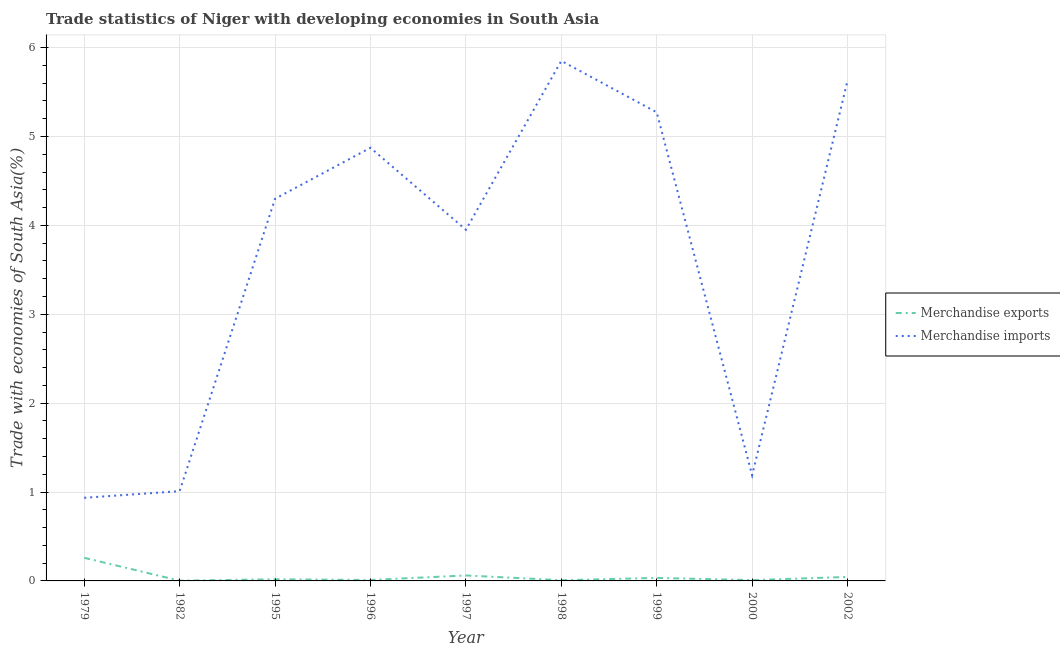What is the merchandise imports in 1982?
Your answer should be very brief. 1.01. Across all years, what is the maximum merchandise imports?
Give a very brief answer. 5.85. Across all years, what is the minimum merchandise imports?
Offer a terse response. 0.94. In which year was the merchandise exports maximum?
Offer a very short reply. 1979. In which year was the merchandise imports minimum?
Keep it short and to the point. 1979. What is the total merchandise imports in the graph?
Your answer should be very brief. 33.01. What is the difference between the merchandise imports in 1979 and that in 1999?
Keep it short and to the point. -4.34. What is the difference between the merchandise exports in 1997 and the merchandise imports in 2002?
Your answer should be very brief. -5.57. What is the average merchandise imports per year?
Provide a succinct answer. 3.67. In the year 2000, what is the difference between the merchandise imports and merchandise exports?
Your answer should be very brief. 1.18. In how many years, is the merchandise imports greater than 1.6 %?
Give a very brief answer. 6. What is the ratio of the merchandise imports in 1998 to that in 1999?
Provide a short and direct response. 1.11. What is the difference between the highest and the second highest merchandise imports?
Provide a short and direct response. 0.22. What is the difference between the highest and the lowest merchandise imports?
Keep it short and to the point. 4.92. Is the sum of the merchandise imports in 1995 and 2000 greater than the maximum merchandise exports across all years?
Keep it short and to the point. Yes. Is the merchandise imports strictly less than the merchandise exports over the years?
Keep it short and to the point. No. How many lines are there?
Your response must be concise. 2. What is the difference between two consecutive major ticks on the Y-axis?
Keep it short and to the point. 1. Are the values on the major ticks of Y-axis written in scientific E-notation?
Give a very brief answer. No. Does the graph contain grids?
Ensure brevity in your answer.  Yes. How many legend labels are there?
Offer a terse response. 2. What is the title of the graph?
Your answer should be compact. Trade statistics of Niger with developing economies in South Asia. What is the label or title of the Y-axis?
Give a very brief answer. Trade with economies of South Asia(%). What is the Trade with economies of South Asia(%) in Merchandise exports in 1979?
Offer a very short reply. 0.26. What is the Trade with economies of South Asia(%) of Merchandise imports in 1979?
Offer a very short reply. 0.94. What is the Trade with economies of South Asia(%) in Merchandise exports in 1982?
Give a very brief answer. 0. What is the Trade with economies of South Asia(%) in Merchandise imports in 1982?
Provide a short and direct response. 1.01. What is the Trade with economies of South Asia(%) of Merchandise exports in 1995?
Provide a short and direct response. 0.02. What is the Trade with economies of South Asia(%) in Merchandise imports in 1995?
Your response must be concise. 4.3. What is the Trade with economies of South Asia(%) in Merchandise exports in 1996?
Provide a short and direct response. 0.01. What is the Trade with economies of South Asia(%) of Merchandise imports in 1996?
Your answer should be very brief. 4.87. What is the Trade with economies of South Asia(%) in Merchandise exports in 1997?
Give a very brief answer. 0.06. What is the Trade with economies of South Asia(%) of Merchandise imports in 1997?
Ensure brevity in your answer.  3.95. What is the Trade with economies of South Asia(%) of Merchandise exports in 1998?
Offer a terse response. 0.01. What is the Trade with economies of South Asia(%) in Merchandise imports in 1998?
Offer a very short reply. 5.85. What is the Trade with economies of South Asia(%) in Merchandise exports in 1999?
Your response must be concise. 0.03. What is the Trade with economies of South Asia(%) in Merchandise imports in 1999?
Offer a very short reply. 5.27. What is the Trade with economies of South Asia(%) of Merchandise exports in 2000?
Your response must be concise. 0.01. What is the Trade with economies of South Asia(%) in Merchandise imports in 2000?
Make the answer very short. 1.19. What is the Trade with economies of South Asia(%) in Merchandise exports in 2002?
Make the answer very short. 0.04. What is the Trade with economies of South Asia(%) of Merchandise imports in 2002?
Provide a short and direct response. 5.63. Across all years, what is the maximum Trade with economies of South Asia(%) of Merchandise exports?
Your answer should be very brief. 0.26. Across all years, what is the maximum Trade with economies of South Asia(%) in Merchandise imports?
Provide a succinct answer. 5.85. Across all years, what is the minimum Trade with economies of South Asia(%) of Merchandise exports?
Your answer should be compact. 0. Across all years, what is the minimum Trade with economies of South Asia(%) in Merchandise imports?
Your answer should be compact. 0.94. What is the total Trade with economies of South Asia(%) in Merchandise exports in the graph?
Your answer should be very brief. 0.45. What is the total Trade with economies of South Asia(%) in Merchandise imports in the graph?
Your answer should be very brief. 33.01. What is the difference between the Trade with economies of South Asia(%) in Merchandise exports in 1979 and that in 1982?
Offer a terse response. 0.26. What is the difference between the Trade with economies of South Asia(%) of Merchandise imports in 1979 and that in 1982?
Your response must be concise. -0.07. What is the difference between the Trade with economies of South Asia(%) of Merchandise exports in 1979 and that in 1995?
Your answer should be very brief. 0.24. What is the difference between the Trade with economies of South Asia(%) in Merchandise imports in 1979 and that in 1995?
Provide a short and direct response. -3.36. What is the difference between the Trade with economies of South Asia(%) in Merchandise exports in 1979 and that in 1996?
Ensure brevity in your answer.  0.25. What is the difference between the Trade with economies of South Asia(%) in Merchandise imports in 1979 and that in 1996?
Offer a terse response. -3.94. What is the difference between the Trade with economies of South Asia(%) of Merchandise exports in 1979 and that in 1997?
Keep it short and to the point. 0.2. What is the difference between the Trade with economies of South Asia(%) in Merchandise imports in 1979 and that in 1997?
Offer a terse response. -3.02. What is the difference between the Trade with economies of South Asia(%) of Merchandise exports in 1979 and that in 1998?
Make the answer very short. 0.25. What is the difference between the Trade with economies of South Asia(%) of Merchandise imports in 1979 and that in 1998?
Offer a very short reply. -4.92. What is the difference between the Trade with economies of South Asia(%) of Merchandise exports in 1979 and that in 1999?
Keep it short and to the point. 0.23. What is the difference between the Trade with economies of South Asia(%) of Merchandise imports in 1979 and that in 1999?
Keep it short and to the point. -4.34. What is the difference between the Trade with economies of South Asia(%) of Merchandise exports in 1979 and that in 2000?
Provide a short and direct response. 0.25. What is the difference between the Trade with economies of South Asia(%) of Merchandise imports in 1979 and that in 2000?
Provide a short and direct response. -0.25. What is the difference between the Trade with economies of South Asia(%) in Merchandise exports in 1979 and that in 2002?
Your response must be concise. 0.22. What is the difference between the Trade with economies of South Asia(%) in Merchandise imports in 1979 and that in 2002?
Provide a short and direct response. -4.69. What is the difference between the Trade with economies of South Asia(%) of Merchandise exports in 1982 and that in 1995?
Give a very brief answer. -0.02. What is the difference between the Trade with economies of South Asia(%) of Merchandise imports in 1982 and that in 1995?
Provide a succinct answer. -3.29. What is the difference between the Trade with economies of South Asia(%) in Merchandise exports in 1982 and that in 1996?
Offer a terse response. -0.01. What is the difference between the Trade with economies of South Asia(%) of Merchandise imports in 1982 and that in 1996?
Provide a short and direct response. -3.86. What is the difference between the Trade with economies of South Asia(%) in Merchandise exports in 1982 and that in 1997?
Your answer should be compact. -0.06. What is the difference between the Trade with economies of South Asia(%) in Merchandise imports in 1982 and that in 1997?
Provide a short and direct response. -2.94. What is the difference between the Trade with economies of South Asia(%) in Merchandise exports in 1982 and that in 1998?
Your answer should be very brief. -0.01. What is the difference between the Trade with economies of South Asia(%) of Merchandise imports in 1982 and that in 1998?
Provide a short and direct response. -4.84. What is the difference between the Trade with economies of South Asia(%) in Merchandise exports in 1982 and that in 1999?
Your answer should be very brief. -0.03. What is the difference between the Trade with economies of South Asia(%) in Merchandise imports in 1982 and that in 1999?
Keep it short and to the point. -4.26. What is the difference between the Trade with economies of South Asia(%) of Merchandise exports in 1982 and that in 2000?
Offer a very short reply. -0.01. What is the difference between the Trade with economies of South Asia(%) in Merchandise imports in 1982 and that in 2000?
Make the answer very short. -0.18. What is the difference between the Trade with economies of South Asia(%) of Merchandise exports in 1982 and that in 2002?
Make the answer very short. -0.04. What is the difference between the Trade with economies of South Asia(%) of Merchandise imports in 1982 and that in 2002?
Keep it short and to the point. -4.62. What is the difference between the Trade with economies of South Asia(%) in Merchandise exports in 1995 and that in 1996?
Provide a succinct answer. 0.01. What is the difference between the Trade with economies of South Asia(%) in Merchandise imports in 1995 and that in 1996?
Make the answer very short. -0.57. What is the difference between the Trade with economies of South Asia(%) in Merchandise exports in 1995 and that in 1997?
Offer a very short reply. -0.04. What is the difference between the Trade with economies of South Asia(%) in Merchandise imports in 1995 and that in 1997?
Your answer should be very brief. 0.35. What is the difference between the Trade with economies of South Asia(%) in Merchandise exports in 1995 and that in 1998?
Offer a very short reply. 0.01. What is the difference between the Trade with economies of South Asia(%) of Merchandise imports in 1995 and that in 1998?
Keep it short and to the point. -1.55. What is the difference between the Trade with economies of South Asia(%) in Merchandise exports in 1995 and that in 1999?
Keep it short and to the point. -0.01. What is the difference between the Trade with economies of South Asia(%) in Merchandise imports in 1995 and that in 1999?
Your response must be concise. -0.97. What is the difference between the Trade with economies of South Asia(%) of Merchandise exports in 1995 and that in 2000?
Your answer should be very brief. 0.01. What is the difference between the Trade with economies of South Asia(%) in Merchandise imports in 1995 and that in 2000?
Provide a short and direct response. 3.11. What is the difference between the Trade with economies of South Asia(%) in Merchandise exports in 1995 and that in 2002?
Provide a short and direct response. -0.03. What is the difference between the Trade with economies of South Asia(%) of Merchandise imports in 1995 and that in 2002?
Make the answer very short. -1.33. What is the difference between the Trade with economies of South Asia(%) in Merchandise exports in 1996 and that in 1997?
Provide a succinct answer. -0.05. What is the difference between the Trade with economies of South Asia(%) in Merchandise imports in 1996 and that in 1997?
Provide a short and direct response. 0.92. What is the difference between the Trade with economies of South Asia(%) of Merchandise exports in 1996 and that in 1998?
Provide a succinct answer. 0. What is the difference between the Trade with economies of South Asia(%) in Merchandise imports in 1996 and that in 1998?
Ensure brevity in your answer.  -0.98. What is the difference between the Trade with economies of South Asia(%) of Merchandise exports in 1996 and that in 1999?
Keep it short and to the point. -0.02. What is the difference between the Trade with economies of South Asia(%) in Merchandise imports in 1996 and that in 1999?
Offer a terse response. -0.4. What is the difference between the Trade with economies of South Asia(%) of Merchandise exports in 1996 and that in 2000?
Offer a very short reply. 0. What is the difference between the Trade with economies of South Asia(%) in Merchandise imports in 1996 and that in 2000?
Make the answer very short. 3.68. What is the difference between the Trade with economies of South Asia(%) of Merchandise exports in 1996 and that in 2002?
Provide a short and direct response. -0.03. What is the difference between the Trade with economies of South Asia(%) in Merchandise imports in 1996 and that in 2002?
Keep it short and to the point. -0.76. What is the difference between the Trade with economies of South Asia(%) of Merchandise exports in 1997 and that in 1998?
Keep it short and to the point. 0.05. What is the difference between the Trade with economies of South Asia(%) in Merchandise imports in 1997 and that in 1998?
Your response must be concise. -1.9. What is the difference between the Trade with economies of South Asia(%) of Merchandise exports in 1997 and that in 1999?
Your answer should be compact. 0.03. What is the difference between the Trade with economies of South Asia(%) of Merchandise imports in 1997 and that in 1999?
Your answer should be very brief. -1.32. What is the difference between the Trade with economies of South Asia(%) in Merchandise exports in 1997 and that in 2000?
Make the answer very short. 0.05. What is the difference between the Trade with economies of South Asia(%) in Merchandise imports in 1997 and that in 2000?
Offer a very short reply. 2.76. What is the difference between the Trade with economies of South Asia(%) in Merchandise exports in 1997 and that in 2002?
Offer a very short reply. 0.02. What is the difference between the Trade with economies of South Asia(%) of Merchandise imports in 1997 and that in 2002?
Keep it short and to the point. -1.68. What is the difference between the Trade with economies of South Asia(%) of Merchandise exports in 1998 and that in 1999?
Make the answer very short. -0.03. What is the difference between the Trade with economies of South Asia(%) of Merchandise imports in 1998 and that in 1999?
Your answer should be compact. 0.58. What is the difference between the Trade with economies of South Asia(%) of Merchandise exports in 1998 and that in 2000?
Ensure brevity in your answer.  -0. What is the difference between the Trade with economies of South Asia(%) in Merchandise imports in 1998 and that in 2000?
Your response must be concise. 4.66. What is the difference between the Trade with economies of South Asia(%) of Merchandise exports in 1998 and that in 2002?
Ensure brevity in your answer.  -0.04. What is the difference between the Trade with economies of South Asia(%) of Merchandise imports in 1998 and that in 2002?
Offer a very short reply. 0.22. What is the difference between the Trade with economies of South Asia(%) of Merchandise exports in 1999 and that in 2000?
Your response must be concise. 0.02. What is the difference between the Trade with economies of South Asia(%) in Merchandise imports in 1999 and that in 2000?
Your answer should be compact. 4.08. What is the difference between the Trade with economies of South Asia(%) of Merchandise exports in 1999 and that in 2002?
Keep it short and to the point. -0.01. What is the difference between the Trade with economies of South Asia(%) in Merchandise imports in 1999 and that in 2002?
Offer a very short reply. -0.36. What is the difference between the Trade with economies of South Asia(%) of Merchandise exports in 2000 and that in 2002?
Your answer should be very brief. -0.04. What is the difference between the Trade with economies of South Asia(%) of Merchandise imports in 2000 and that in 2002?
Give a very brief answer. -4.44. What is the difference between the Trade with economies of South Asia(%) of Merchandise exports in 1979 and the Trade with economies of South Asia(%) of Merchandise imports in 1982?
Ensure brevity in your answer.  -0.75. What is the difference between the Trade with economies of South Asia(%) of Merchandise exports in 1979 and the Trade with economies of South Asia(%) of Merchandise imports in 1995?
Provide a short and direct response. -4.04. What is the difference between the Trade with economies of South Asia(%) in Merchandise exports in 1979 and the Trade with economies of South Asia(%) in Merchandise imports in 1996?
Keep it short and to the point. -4.61. What is the difference between the Trade with economies of South Asia(%) in Merchandise exports in 1979 and the Trade with economies of South Asia(%) in Merchandise imports in 1997?
Your answer should be compact. -3.69. What is the difference between the Trade with economies of South Asia(%) in Merchandise exports in 1979 and the Trade with economies of South Asia(%) in Merchandise imports in 1998?
Provide a short and direct response. -5.59. What is the difference between the Trade with economies of South Asia(%) in Merchandise exports in 1979 and the Trade with economies of South Asia(%) in Merchandise imports in 1999?
Your answer should be very brief. -5.01. What is the difference between the Trade with economies of South Asia(%) in Merchandise exports in 1979 and the Trade with economies of South Asia(%) in Merchandise imports in 2000?
Your answer should be compact. -0.93. What is the difference between the Trade with economies of South Asia(%) of Merchandise exports in 1979 and the Trade with economies of South Asia(%) of Merchandise imports in 2002?
Give a very brief answer. -5.37. What is the difference between the Trade with economies of South Asia(%) in Merchandise exports in 1982 and the Trade with economies of South Asia(%) in Merchandise imports in 1995?
Provide a succinct answer. -4.3. What is the difference between the Trade with economies of South Asia(%) in Merchandise exports in 1982 and the Trade with economies of South Asia(%) in Merchandise imports in 1996?
Make the answer very short. -4.87. What is the difference between the Trade with economies of South Asia(%) in Merchandise exports in 1982 and the Trade with economies of South Asia(%) in Merchandise imports in 1997?
Your answer should be compact. -3.95. What is the difference between the Trade with economies of South Asia(%) of Merchandise exports in 1982 and the Trade with economies of South Asia(%) of Merchandise imports in 1998?
Provide a short and direct response. -5.85. What is the difference between the Trade with economies of South Asia(%) of Merchandise exports in 1982 and the Trade with economies of South Asia(%) of Merchandise imports in 1999?
Provide a succinct answer. -5.27. What is the difference between the Trade with economies of South Asia(%) in Merchandise exports in 1982 and the Trade with economies of South Asia(%) in Merchandise imports in 2000?
Your answer should be compact. -1.19. What is the difference between the Trade with economies of South Asia(%) of Merchandise exports in 1982 and the Trade with economies of South Asia(%) of Merchandise imports in 2002?
Keep it short and to the point. -5.63. What is the difference between the Trade with economies of South Asia(%) of Merchandise exports in 1995 and the Trade with economies of South Asia(%) of Merchandise imports in 1996?
Offer a terse response. -4.85. What is the difference between the Trade with economies of South Asia(%) of Merchandise exports in 1995 and the Trade with economies of South Asia(%) of Merchandise imports in 1997?
Give a very brief answer. -3.93. What is the difference between the Trade with economies of South Asia(%) in Merchandise exports in 1995 and the Trade with economies of South Asia(%) in Merchandise imports in 1998?
Give a very brief answer. -5.83. What is the difference between the Trade with economies of South Asia(%) in Merchandise exports in 1995 and the Trade with economies of South Asia(%) in Merchandise imports in 1999?
Your answer should be very brief. -5.25. What is the difference between the Trade with economies of South Asia(%) of Merchandise exports in 1995 and the Trade with economies of South Asia(%) of Merchandise imports in 2000?
Offer a terse response. -1.17. What is the difference between the Trade with economies of South Asia(%) of Merchandise exports in 1995 and the Trade with economies of South Asia(%) of Merchandise imports in 2002?
Your answer should be very brief. -5.61. What is the difference between the Trade with economies of South Asia(%) in Merchandise exports in 1996 and the Trade with economies of South Asia(%) in Merchandise imports in 1997?
Make the answer very short. -3.94. What is the difference between the Trade with economies of South Asia(%) of Merchandise exports in 1996 and the Trade with economies of South Asia(%) of Merchandise imports in 1998?
Keep it short and to the point. -5.84. What is the difference between the Trade with economies of South Asia(%) in Merchandise exports in 1996 and the Trade with economies of South Asia(%) in Merchandise imports in 1999?
Your response must be concise. -5.26. What is the difference between the Trade with economies of South Asia(%) in Merchandise exports in 1996 and the Trade with economies of South Asia(%) in Merchandise imports in 2000?
Your answer should be very brief. -1.18. What is the difference between the Trade with economies of South Asia(%) of Merchandise exports in 1996 and the Trade with economies of South Asia(%) of Merchandise imports in 2002?
Your answer should be compact. -5.62. What is the difference between the Trade with economies of South Asia(%) in Merchandise exports in 1997 and the Trade with economies of South Asia(%) in Merchandise imports in 1998?
Give a very brief answer. -5.79. What is the difference between the Trade with economies of South Asia(%) of Merchandise exports in 1997 and the Trade with economies of South Asia(%) of Merchandise imports in 1999?
Provide a short and direct response. -5.21. What is the difference between the Trade with economies of South Asia(%) in Merchandise exports in 1997 and the Trade with economies of South Asia(%) in Merchandise imports in 2000?
Offer a terse response. -1.13. What is the difference between the Trade with economies of South Asia(%) of Merchandise exports in 1997 and the Trade with economies of South Asia(%) of Merchandise imports in 2002?
Make the answer very short. -5.57. What is the difference between the Trade with economies of South Asia(%) of Merchandise exports in 1998 and the Trade with economies of South Asia(%) of Merchandise imports in 1999?
Make the answer very short. -5.26. What is the difference between the Trade with economies of South Asia(%) in Merchandise exports in 1998 and the Trade with economies of South Asia(%) in Merchandise imports in 2000?
Offer a very short reply. -1.18. What is the difference between the Trade with economies of South Asia(%) of Merchandise exports in 1998 and the Trade with economies of South Asia(%) of Merchandise imports in 2002?
Give a very brief answer. -5.62. What is the difference between the Trade with economies of South Asia(%) of Merchandise exports in 1999 and the Trade with economies of South Asia(%) of Merchandise imports in 2000?
Give a very brief answer. -1.16. What is the difference between the Trade with economies of South Asia(%) of Merchandise exports in 1999 and the Trade with economies of South Asia(%) of Merchandise imports in 2002?
Keep it short and to the point. -5.6. What is the difference between the Trade with economies of South Asia(%) of Merchandise exports in 2000 and the Trade with economies of South Asia(%) of Merchandise imports in 2002?
Keep it short and to the point. -5.62. What is the average Trade with economies of South Asia(%) in Merchandise imports per year?
Your answer should be compact. 3.67. In the year 1979, what is the difference between the Trade with economies of South Asia(%) of Merchandise exports and Trade with economies of South Asia(%) of Merchandise imports?
Provide a short and direct response. -0.67. In the year 1982, what is the difference between the Trade with economies of South Asia(%) in Merchandise exports and Trade with economies of South Asia(%) in Merchandise imports?
Your response must be concise. -1.01. In the year 1995, what is the difference between the Trade with economies of South Asia(%) in Merchandise exports and Trade with economies of South Asia(%) in Merchandise imports?
Your answer should be compact. -4.28. In the year 1996, what is the difference between the Trade with economies of South Asia(%) in Merchandise exports and Trade with economies of South Asia(%) in Merchandise imports?
Provide a succinct answer. -4.86. In the year 1997, what is the difference between the Trade with economies of South Asia(%) in Merchandise exports and Trade with economies of South Asia(%) in Merchandise imports?
Your answer should be compact. -3.89. In the year 1998, what is the difference between the Trade with economies of South Asia(%) in Merchandise exports and Trade with economies of South Asia(%) in Merchandise imports?
Make the answer very short. -5.84. In the year 1999, what is the difference between the Trade with economies of South Asia(%) in Merchandise exports and Trade with economies of South Asia(%) in Merchandise imports?
Keep it short and to the point. -5.24. In the year 2000, what is the difference between the Trade with economies of South Asia(%) of Merchandise exports and Trade with economies of South Asia(%) of Merchandise imports?
Provide a short and direct response. -1.18. In the year 2002, what is the difference between the Trade with economies of South Asia(%) of Merchandise exports and Trade with economies of South Asia(%) of Merchandise imports?
Your answer should be compact. -5.58. What is the ratio of the Trade with economies of South Asia(%) in Merchandise exports in 1979 to that in 1982?
Ensure brevity in your answer.  95.98. What is the ratio of the Trade with economies of South Asia(%) of Merchandise imports in 1979 to that in 1982?
Keep it short and to the point. 0.93. What is the ratio of the Trade with economies of South Asia(%) of Merchandise exports in 1979 to that in 1995?
Make the answer very short. 13.91. What is the ratio of the Trade with economies of South Asia(%) of Merchandise imports in 1979 to that in 1995?
Your answer should be compact. 0.22. What is the ratio of the Trade with economies of South Asia(%) of Merchandise exports in 1979 to that in 1996?
Your answer should be compact. 24.33. What is the ratio of the Trade with economies of South Asia(%) in Merchandise imports in 1979 to that in 1996?
Your response must be concise. 0.19. What is the ratio of the Trade with economies of South Asia(%) in Merchandise exports in 1979 to that in 1997?
Your answer should be very brief. 4.23. What is the ratio of the Trade with economies of South Asia(%) of Merchandise imports in 1979 to that in 1997?
Keep it short and to the point. 0.24. What is the ratio of the Trade with economies of South Asia(%) of Merchandise exports in 1979 to that in 1998?
Make the answer very short. 31.63. What is the ratio of the Trade with economies of South Asia(%) in Merchandise imports in 1979 to that in 1998?
Keep it short and to the point. 0.16. What is the ratio of the Trade with economies of South Asia(%) of Merchandise exports in 1979 to that in 1999?
Ensure brevity in your answer.  7.73. What is the ratio of the Trade with economies of South Asia(%) of Merchandise imports in 1979 to that in 1999?
Your answer should be very brief. 0.18. What is the ratio of the Trade with economies of South Asia(%) in Merchandise exports in 1979 to that in 2000?
Give a very brief answer. 27.89. What is the ratio of the Trade with economies of South Asia(%) in Merchandise imports in 1979 to that in 2000?
Offer a very short reply. 0.79. What is the ratio of the Trade with economies of South Asia(%) in Merchandise exports in 1979 to that in 2002?
Give a very brief answer. 5.8. What is the ratio of the Trade with economies of South Asia(%) in Merchandise imports in 1979 to that in 2002?
Make the answer very short. 0.17. What is the ratio of the Trade with economies of South Asia(%) in Merchandise exports in 1982 to that in 1995?
Give a very brief answer. 0.14. What is the ratio of the Trade with economies of South Asia(%) in Merchandise imports in 1982 to that in 1995?
Give a very brief answer. 0.23. What is the ratio of the Trade with economies of South Asia(%) in Merchandise exports in 1982 to that in 1996?
Your answer should be compact. 0.25. What is the ratio of the Trade with economies of South Asia(%) in Merchandise imports in 1982 to that in 1996?
Your response must be concise. 0.21. What is the ratio of the Trade with economies of South Asia(%) of Merchandise exports in 1982 to that in 1997?
Give a very brief answer. 0.04. What is the ratio of the Trade with economies of South Asia(%) of Merchandise imports in 1982 to that in 1997?
Offer a terse response. 0.26. What is the ratio of the Trade with economies of South Asia(%) of Merchandise exports in 1982 to that in 1998?
Keep it short and to the point. 0.33. What is the ratio of the Trade with economies of South Asia(%) of Merchandise imports in 1982 to that in 1998?
Your answer should be very brief. 0.17. What is the ratio of the Trade with economies of South Asia(%) of Merchandise exports in 1982 to that in 1999?
Give a very brief answer. 0.08. What is the ratio of the Trade with economies of South Asia(%) of Merchandise imports in 1982 to that in 1999?
Give a very brief answer. 0.19. What is the ratio of the Trade with economies of South Asia(%) in Merchandise exports in 1982 to that in 2000?
Provide a succinct answer. 0.29. What is the ratio of the Trade with economies of South Asia(%) of Merchandise imports in 1982 to that in 2000?
Offer a terse response. 0.85. What is the ratio of the Trade with economies of South Asia(%) in Merchandise exports in 1982 to that in 2002?
Ensure brevity in your answer.  0.06. What is the ratio of the Trade with economies of South Asia(%) in Merchandise imports in 1982 to that in 2002?
Your answer should be very brief. 0.18. What is the ratio of the Trade with economies of South Asia(%) in Merchandise exports in 1995 to that in 1996?
Give a very brief answer. 1.75. What is the ratio of the Trade with economies of South Asia(%) of Merchandise imports in 1995 to that in 1996?
Give a very brief answer. 0.88. What is the ratio of the Trade with economies of South Asia(%) in Merchandise exports in 1995 to that in 1997?
Offer a very short reply. 0.3. What is the ratio of the Trade with economies of South Asia(%) of Merchandise imports in 1995 to that in 1997?
Offer a very short reply. 1.09. What is the ratio of the Trade with economies of South Asia(%) in Merchandise exports in 1995 to that in 1998?
Ensure brevity in your answer.  2.27. What is the ratio of the Trade with economies of South Asia(%) of Merchandise imports in 1995 to that in 1998?
Provide a succinct answer. 0.73. What is the ratio of the Trade with economies of South Asia(%) of Merchandise exports in 1995 to that in 1999?
Give a very brief answer. 0.56. What is the ratio of the Trade with economies of South Asia(%) in Merchandise imports in 1995 to that in 1999?
Offer a very short reply. 0.82. What is the ratio of the Trade with economies of South Asia(%) of Merchandise exports in 1995 to that in 2000?
Make the answer very short. 2.01. What is the ratio of the Trade with economies of South Asia(%) in Merchandise imports in 1995 to that in 2000?
Your answer should be compact. 3.62. What is the ratio of the Trade with economies of South Asia(%) of Merchandise exports in 1995 to that in 2002?
Your answer should be compact. 0.42. What is the ratio of the Trade with economies of South Asia(%) in Merchandise imports in 1995 to that in 2002?
Offer a terse response. 0.76. What is the ratio of the Trade with economies of South Asia(%) in Merchandise exports in 1996 to that in 1997?
Your answer should be very brief. 0.17. What is the ratio of the Trade with economies of South Asia(%) in Merchandise imports in 1996 to that in 1997?
Your response must be concise. 1.23. What is the ratio of the Trade with economies of South Asia(%) in Merchandise exports in 1996 to that in 1998?
Give a very brief answer. 1.3. What is the ratio of the Trade with economies of South Asia(%) in Merchandise imports in 1996 to that in 1998?
Make the answer very short. 0.83. What is the ratio of the Trade with economies of South Asia(%) in Merchandise exports in 1996 to that in 1999?
Make the answer very short. 0.32. What is the ratio of the Trade with economies of South Asia(%) in Merchandise imports in 1996 to that in 1999?
Provide a succinct answer. 0.92. What is the ratio of the Trade with economies of South Asia(%) of Merchandise exports in 1996 to that in 2000?
Offer a very short reply. 1.15. What is the ratio of the Trade with economies of South Asia(%) in Merchandise imports in 1996 to that in 2000?
Provide a short and direct response. 4.1. What is the ratio of the Trade with economies of South Asia(%) in Merchandise exports in 1996 to that in 2002?
Your answer should be very brief. 0.24. What is the ratio of the Trade with economies of South Asia(%) in Merchandise imports in 1996 to that in 2002?
Keep it short and to the point. 0.87. What is the ratio of the Trade with economies of South Asia(%) in Merchandise exports in 1997 to that in 1998?
Keep it short and to the point. 7.48. What is the ratio of the Trade with economies of South Asia(%) of Merchandise imports in 1997 to that in 1998?
Make the answer very short. 0.68. What is the ratio of the Trade with economies of South Asia(%) in Merchandise exports in 1997 to that in 1999?
Provide a short and direct response. 1.83. What is the ratio of the Trade with economies of South Asia(%) of Merchandise imports in 1997 to that in 1999?
Offer a terse response. 0.75. What is the ratio of the Trade with economies of South Asia(%) of Merchandise exports in 1997 to that in 2000?
Make the answer very short. 6.59. What is the ratio of the Trade with economies of South Asia(%) of Merchandise imports in 1997 to that in 2000?
Give a very brief answer. 3.32. What is the ratio of the Trade with economies of South Asia(%) of Merchandise exports in 1997 to that in 2002?
Your response must be concise. 1.37. What is the ratio of the Trade with economies of South Asia(%) of Merchandise imports in 1997 to that in 2002?
Provide a short and direct response. 0.7. What is the ratio of the Trade with economies of South Asia(%) of Merchandise exports in 1998 to that in 1999?
Your answer should be compact. 0.24. What is the ratio of the Trade with economies of South Asia(%) in Merchandise imports in 1998 to that in 1999?
Offer a terse response. 1.11. What is the ratio of the Trade with economies of South Asia(%) of Merchandise exports in 1998 to that in 2000?
Offer a terse response. 0.88. What is the ratio of the Trade with economies of South Asia(%) of Merchandise imports in 1998 to that in 2000?
Provide a short and direct response. 4.92. What is the ratio of the Trade with economies of South Asia(%) in Merchandise exports in 1998 to that in 2002?
Offer a terse response. 0.18. What is the ratio of the Trade with economies of South Asia(%) in Merchandise imports in 1998 to that in 2002?
Ensure brevity in your answer.  1.04. What is the ratio of the Trade with economies of South Asia(%) in Merchandise exports in 1999 to that in 2000?
Give a very brief answer. 3.61. What is the ratio of the Trade with economies of South Asia(%) of Merchandise imports in 1999 to that in 2000?
Your response must be concise. 4.43. What is the ratio of the Trade with economies of South Asia(%) in Merchandise exports in 1999 to that in 2002?
Provide a short and direct response. 0.75. What is the ratio of the Trade with economies of South Asia(%) of Merchandise imports in 1999 to that in 2002?
Keep it short and to the point. 0.94. What is the ratio of the Trade with economies of South Asia(%) in Merchandise exports in 2000 to that in 2002?
Offer a terse response. 0.21. What is the ratio of the Trade with economies of South Asia(%) of Merchandise imports in 2000 to that in 2002?
Your response must be concise. 0.21. What is the difference between the highest and the second highest Trade with economies of South Asia(%) in Merchandise exports?
Provide a succinct answer. 0.2. What is the difference between the highest and the second highest Trade with economies of South Asia(%) in Merchandise imports?
Your answer should be compact. 0.22. What is the difference between the highest and the lowest Trade with economies of South Asia(%) of Merchandise exports?
Keep it short and to the point. 0.26. What is the difference between the highest and the lowest Trade with economies of South Asia(%) of Merchandise imports?
Your response must be concise. 4.92. 